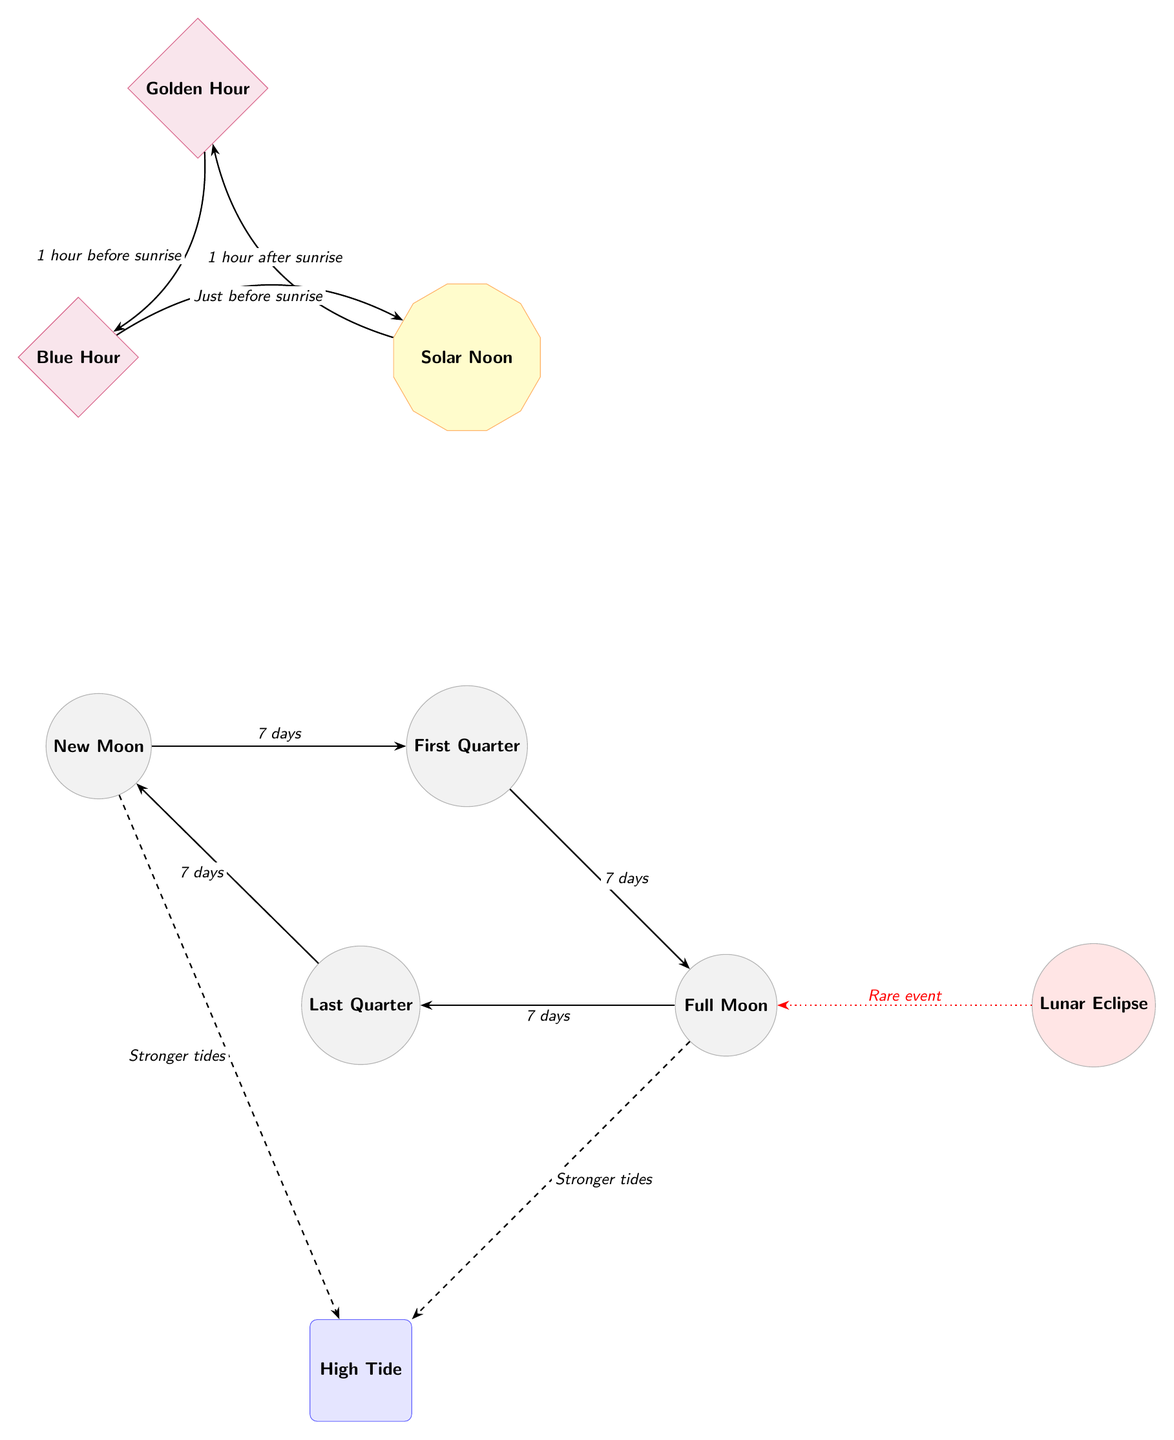What's the duration between New Moon and First Quarter? The diagram indicates that the duration is 7 days, as shown by the arrow between the New Moon and First Quarter nodes.
Answer: 7 days Which phase follows Full Moon? According to the diagram, the phase that follows Full Moon is the Last Quarter, which is directly illustrated to the left of the Full Moon node.
Answer: Last Quarter What is indicated by the dashed arrow from Full Moon to High Tide? The dashed arrow from Full Moon to High Tide indicates stronger tides during that phase, as labeled by the corresponding text.
Answer: Stronger tides How many types of hours are represented in the diagram? The diagram features two types of hours: Golden Hour and Blue Hour, as evident from the two hour nodes connected to Solar Noon.
Answer: 2 What rare event is associated with the Full Moon in the diagram? The diagram connects the Lunar Eclipse to the Full Moon node with a dotted red line, indicating this as a rare event occurring during that phase.
Answer: Lunar Eclipse What are the two types of lunar phases depicted in the diagram? The diagram illustrates four distinct lunar phases: New Moon, First Quarter, Full Moon, and Last Quarter, all represented as moon nodes.
Answer: New Moon and Full Moon What is the sequence of events from Solar Noon to Blue Hour? The diagram shows that from Solar Noon, you first move to Golden Hour and then to Blue Hour, following the arrows that dictate the progression of time.
Answer: Solar Noon to Blue Hour How many days are there between the phases in the lunar cycle? Each transition between the lunar phases is clearly labeled with the same duration of 7 days, indicating uniformity throughout the cycle.
Answer: 7 days 